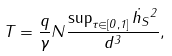<formula> <loc_0><loc_0><loc_500><loc_500>T = \frac { q } { \gamma } N \frac { \sup _ { \tau \in [ 0 , 1 ] } \| \dot { h } _ { S } \| ^ { 2 } } { d ^ { 3 } } ,</formula> 